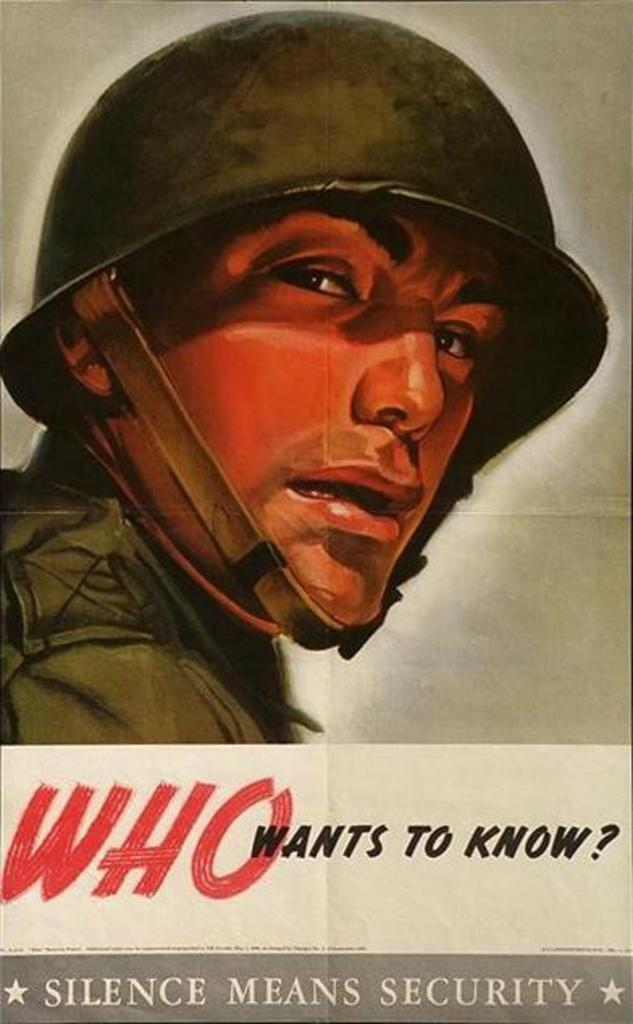<image>
Present a compact description of the photo's key features. A poster of a man from the military with the writing who wants to know, silence means security. 